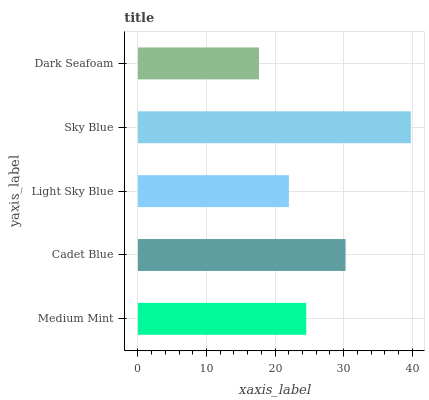Is Dark Seafoam the minimum?
Answer yes or no. Yes. Is Sky Blue the maximum?
Answer yes or no. Yes. Is Cadet Blue the minimum?
Answer yes or no. No. Is Cadet Blue the maximum?
Answer yes or no. No. Is Cadet Blue greater than Medium Mint?
Answer yes or no. Yes. Is Medium Mint less than Cadet Blue?
Answer yes or no. Yes. Is Medium Mint greater than Cadet Blue?
Answer yes or no. No. Is Cadet Blue less than Medium Mint?
Answer yes or no. No. Is Medium Mint the high median?
Answer yes or no. Yes. Is Medium Mint the low median?
Answer yes or no. Yes. Is Cadet Blue the high median?
Answer yes or no. No. Is Sky Blue the low median?
Answer yes or no. No. 